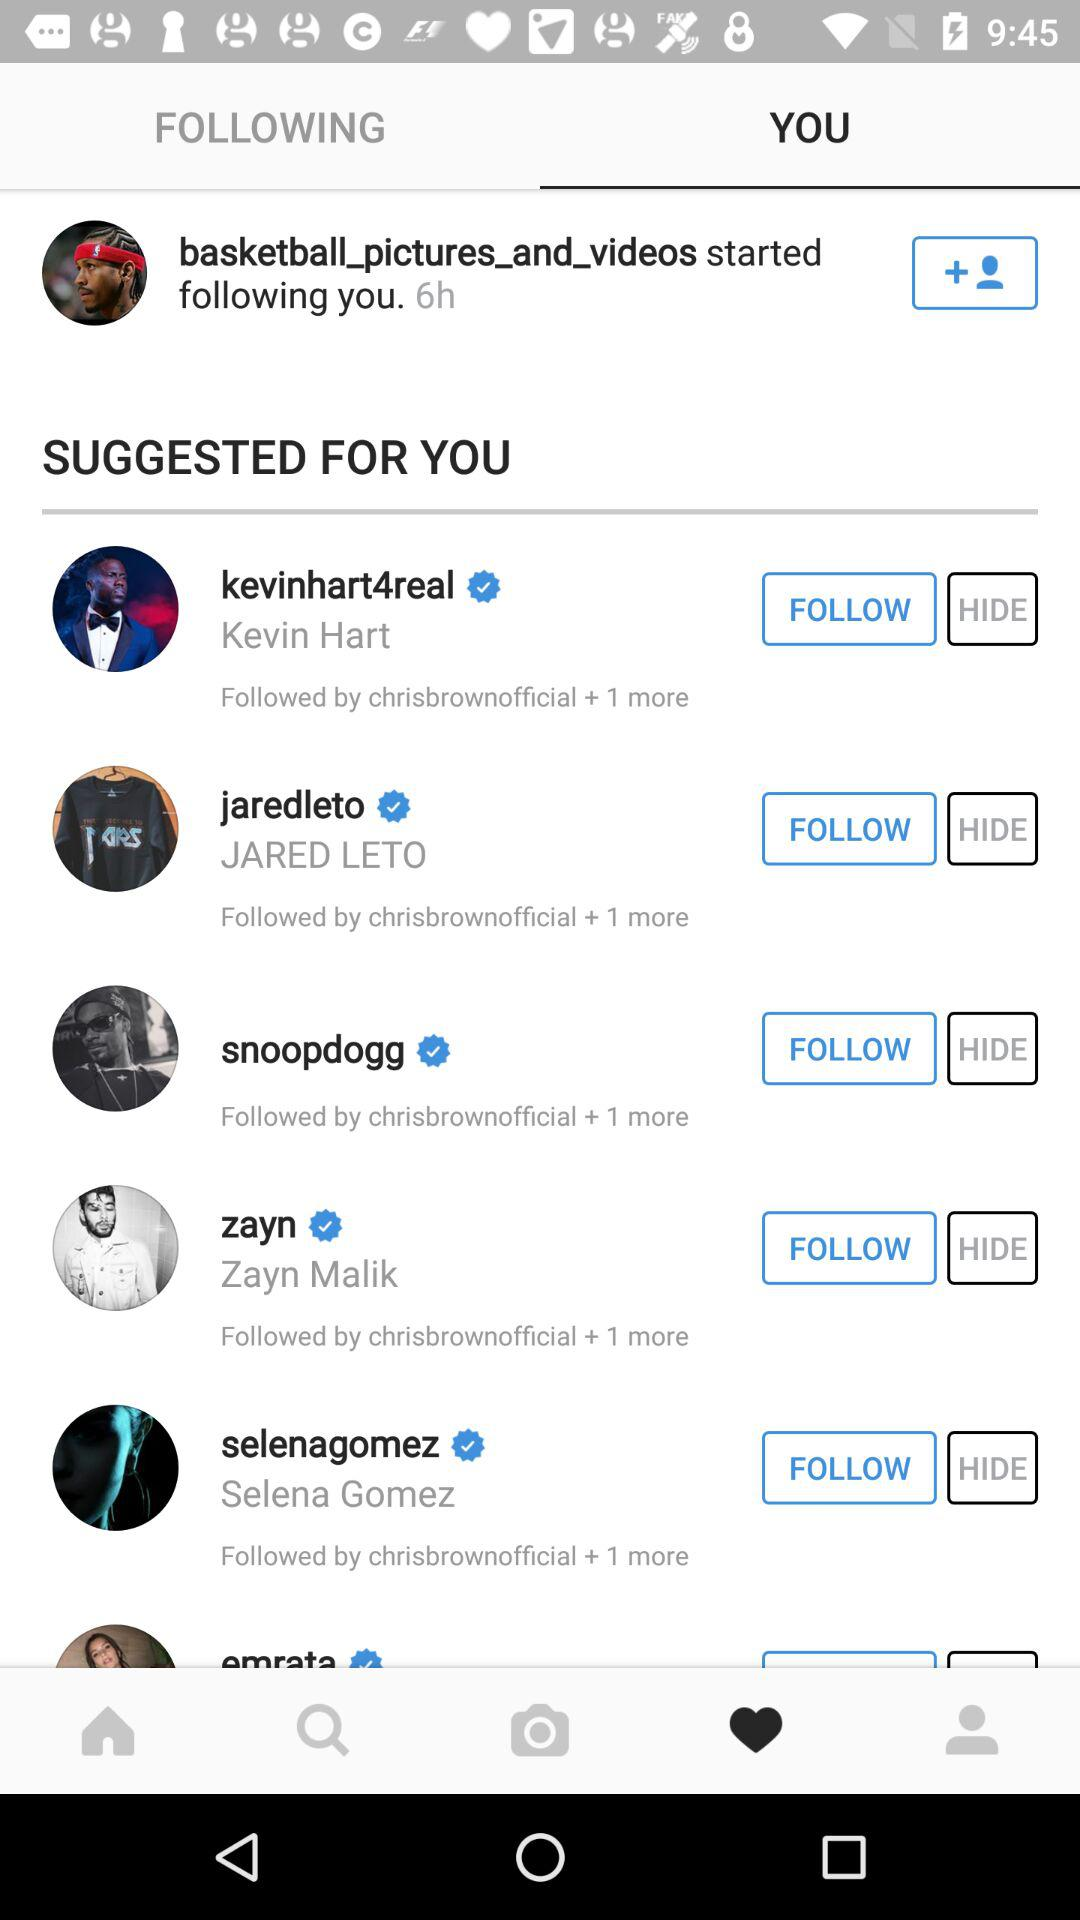How many suggested for you items are there?
Answer the question using a single word or phrase. 6 